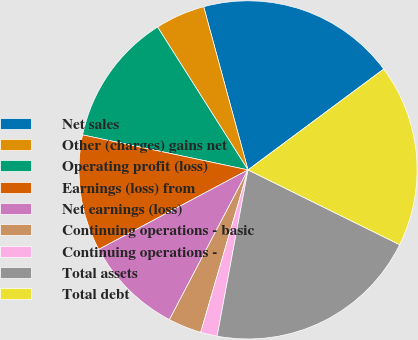<chart> <loc_0><loc_0><loc_500><loc_500><pie_chart><fcel>Net sales<fcel>Other (charges) gains net<fcel>Operating profit (loss)<fcel>Earnings (loss) from<fcel>Net earnings (loss)<fcel>Continuing operations - basic<fcel>Continuing operations -<fcel>Total assets<fcel>Total debt<nl><fcel>19.05%<fcel>4.76%<fcel>12.7%<fcel>11.11%<fcel>9.52%<fcel>3.18%<fcel>1.59%<fcel>20.63%<fcel>17.46%<nl></chart> 